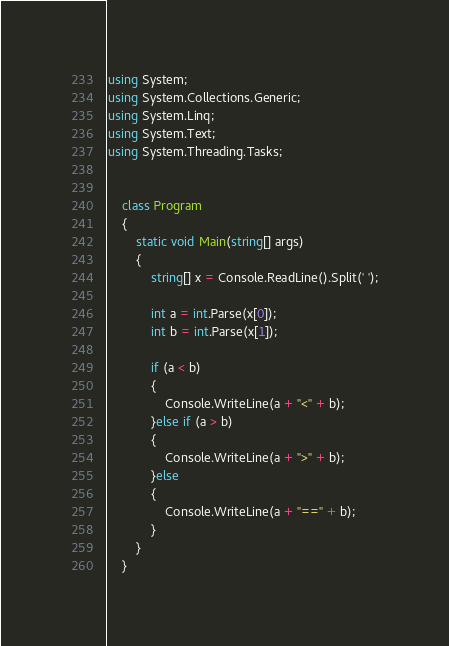<code> <loc_0><loc_0><loc_500><loc_500><_C#_>using System;
using System.Collections.Generic;
using System.Linq;
using System.Text;
using System.Threading.Tasks;


    class Program
    {
        static void Main(string[] args)
        {
            string[] x = Console.ReadLine().Split(' ');

            int a = int.Parse(x[0]);
            int b = int.Parse(x[1]);

            if (a < b)
            {
                Console.WriteLine(a + "<" + b);
            }else if (a > b)
            {
                Console.WriteLine(a + ">" + b);
            }else
            {
                Console.WriteLine(a + "==" + b);
            }
        }
    }


</code> 